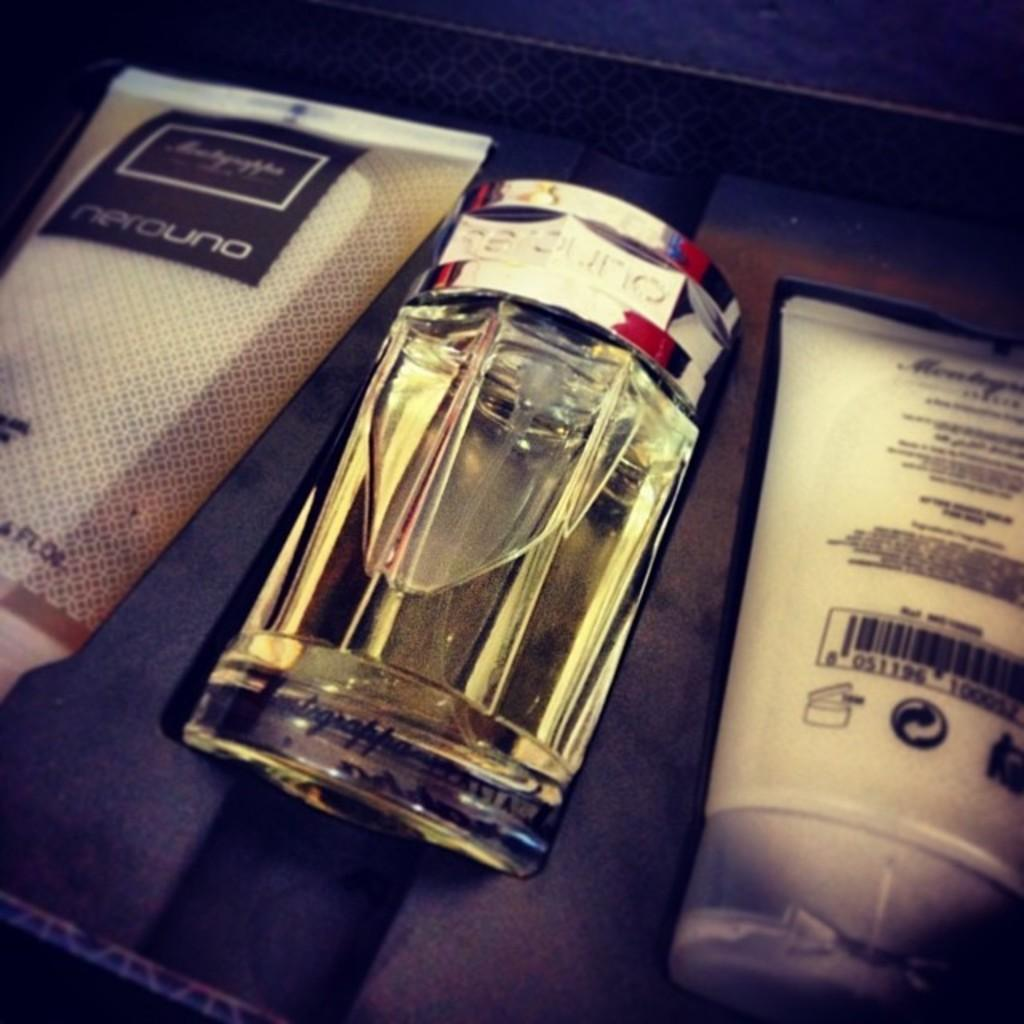<image>
Offer a succinct explanation of the picture presented. the word nerouno is on the item next to a glass item 